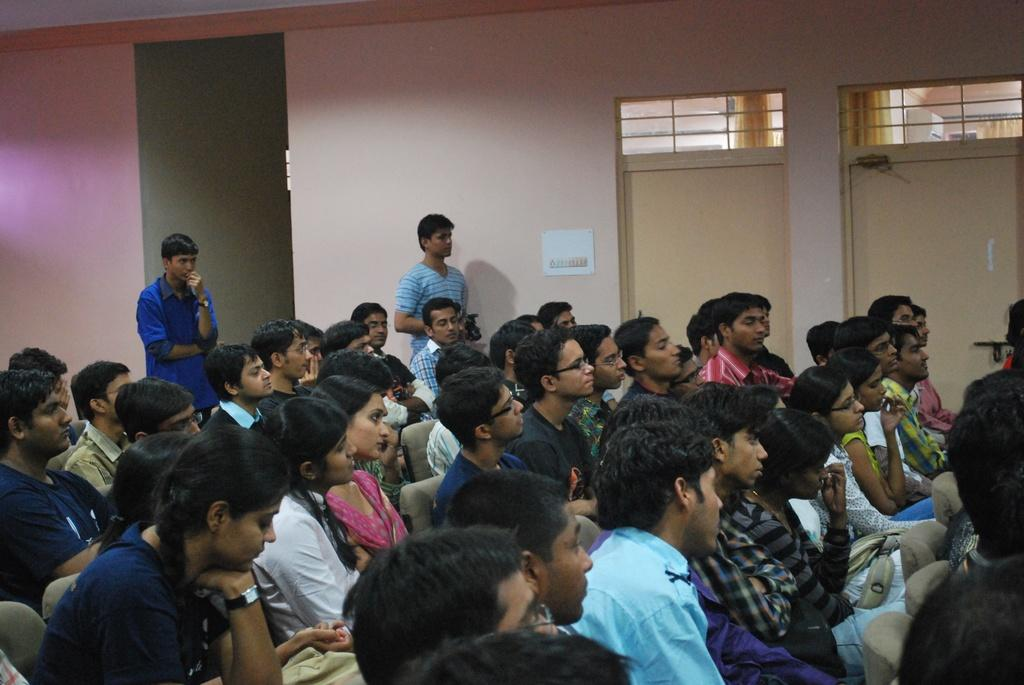What are the people in the image doing? There is a group of people sitting on chairs in the image. Are there any people standing in the image? Yes, there are two people standing in the image. What architectural features can be seen in the image? There are doors visible in the image. What type of structure is present in the image? There is a wall in the image. What type of sock is being passed around during the lunch in the image? There is no mention of a sock or lunch in the image; it only shows people sitting and standing with doors and a wall visible. 